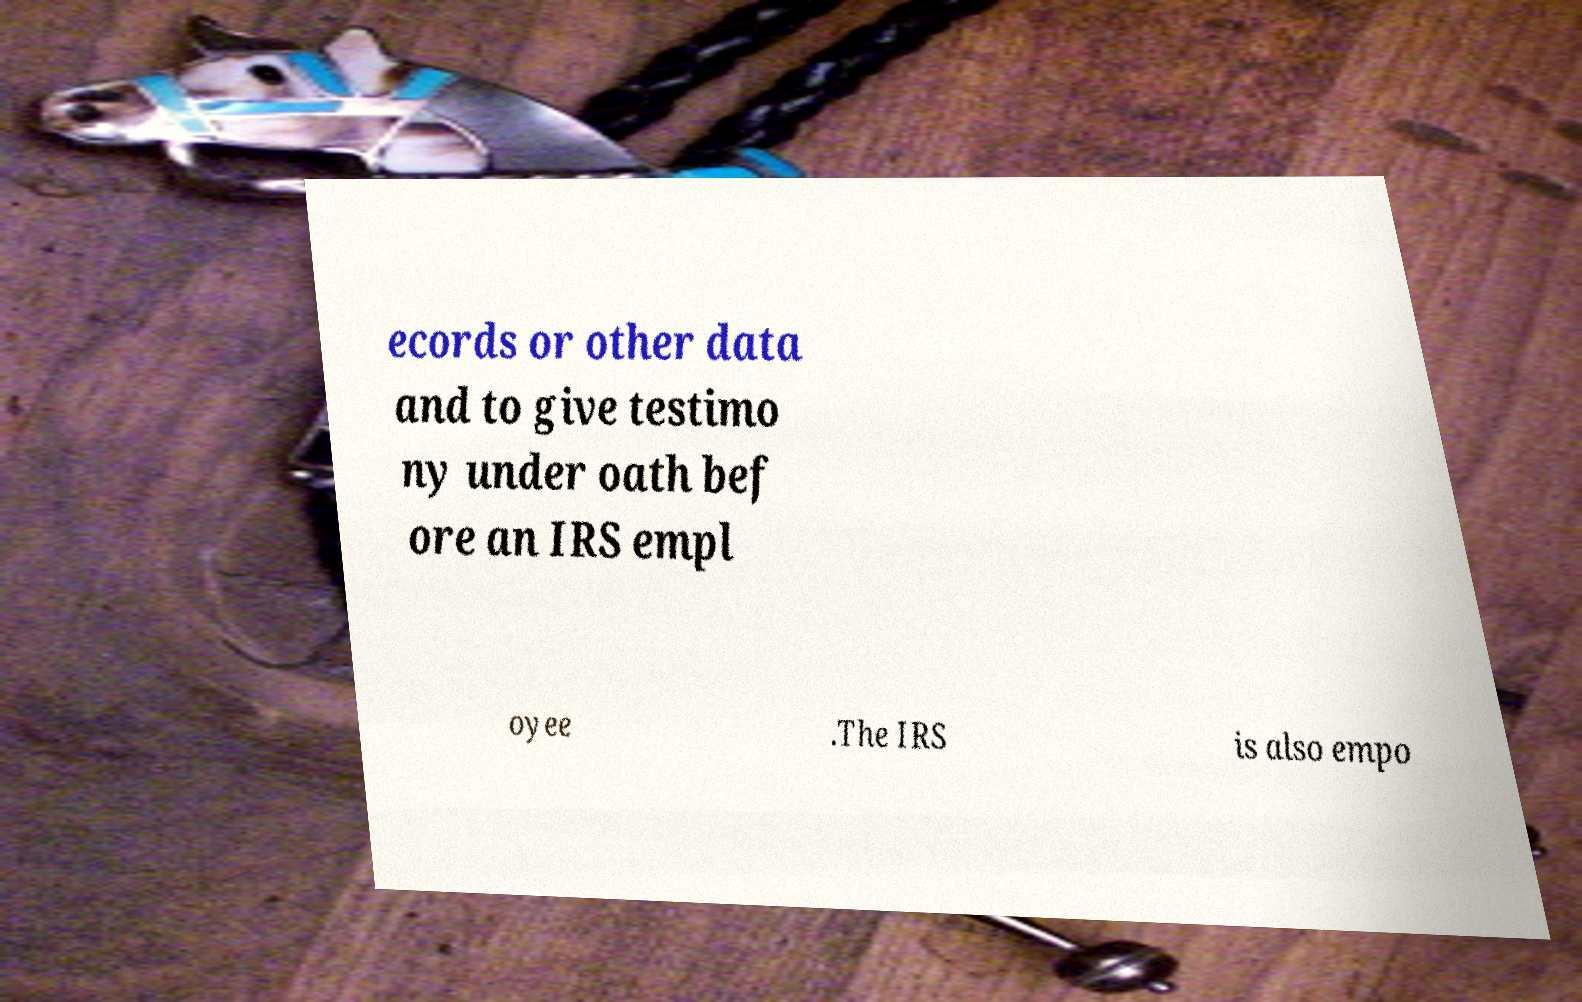There's text embedded in this image that I need extracted. Can you transcribe it verbatim? ecords or other data and to give testimo ny under oath bef ore an IRS empl oyee .The IRS is also empo 